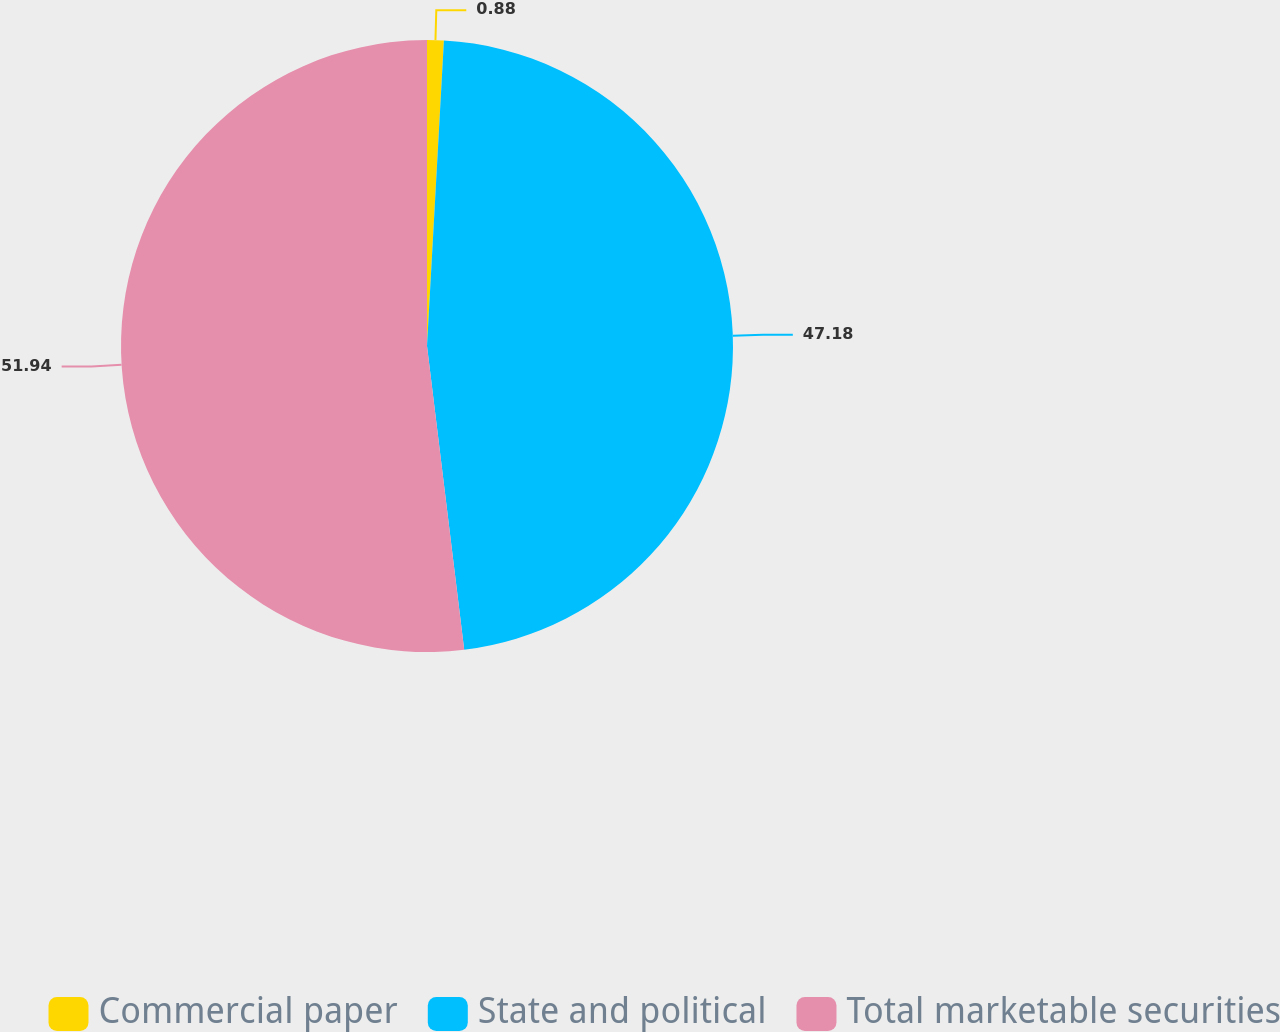Convert chart to OTSL. <chart><loc_0><loc_0><loc_500><loc_500><pie_chart><fcel>Commercial paper<fcel>State and political<fcel>Total marketable securities<nl><fcel>0.88%<fcel>47.18%<fcel>51.94%<nl></chart> 